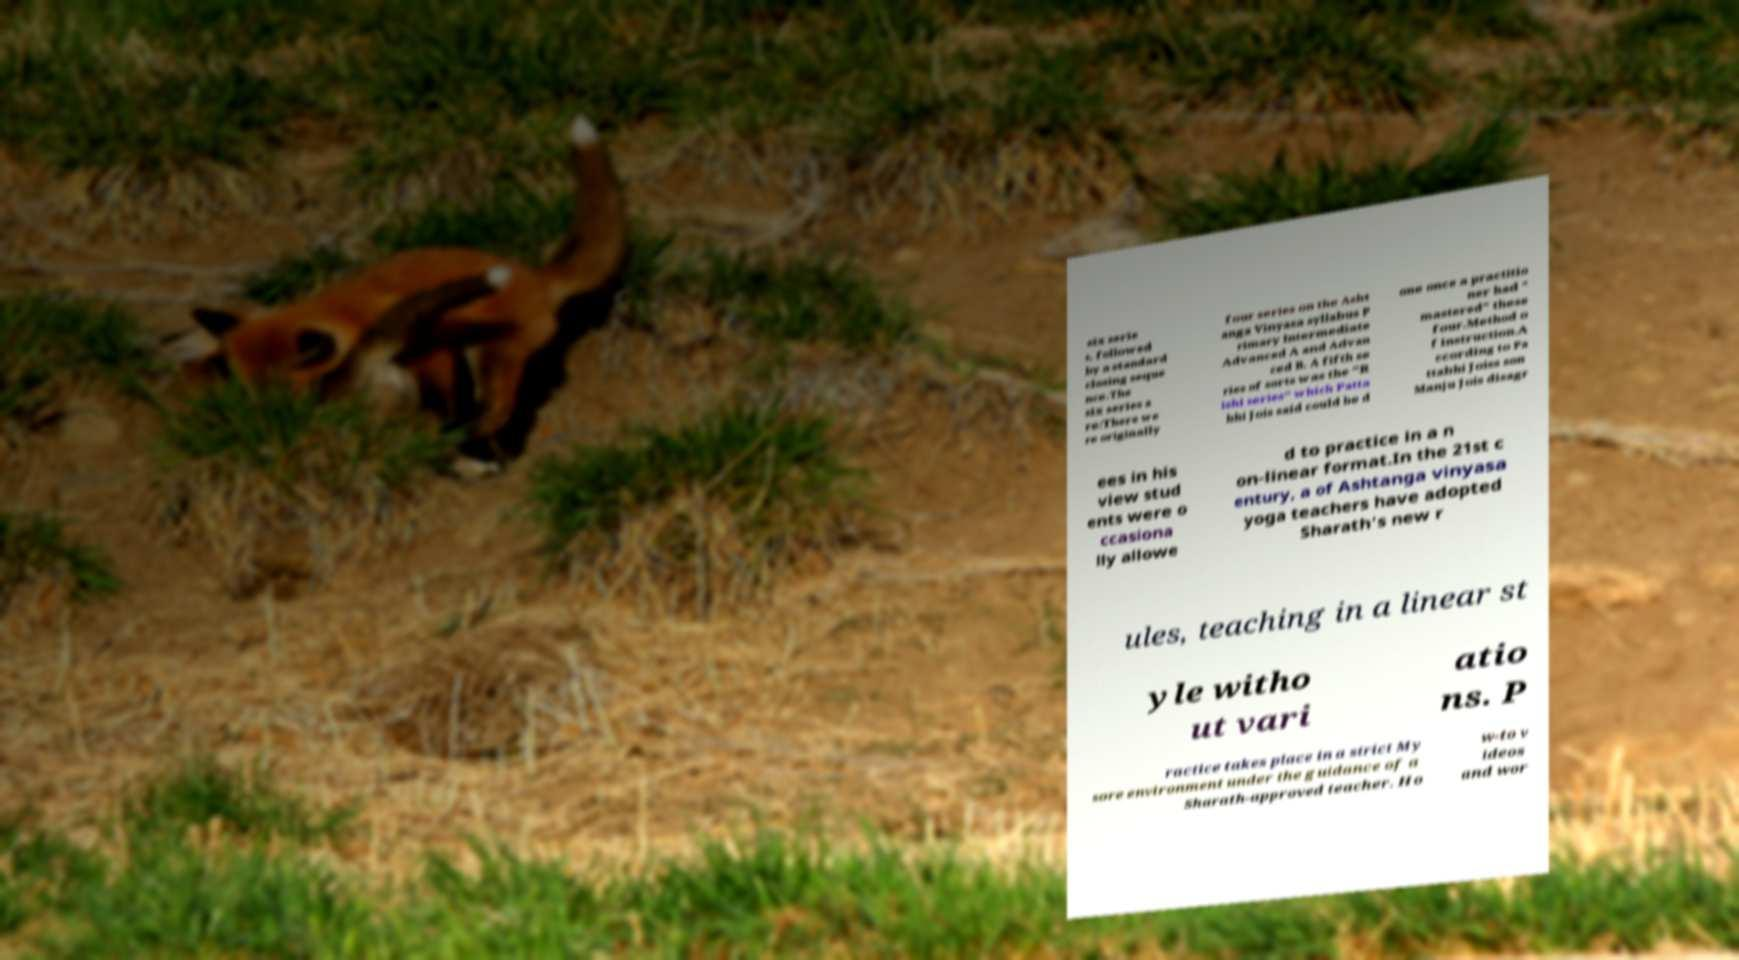Can you read and provide the text displayed in the image?This photo seems to have some interesting text. Can you extract and type it out for me? six serie s, followed by a standard closing seque nce.The six series a re:There we re originally four series on the Asht anga Vinyasa syllabus P rimary Intermediate Advanced A and Advan ced B. A fifth se ries of sorts was the "R ishi series" which Patta bhi Jois said could be d one once a practitio ner had " mastered" these four.Method o f instruction.A ccording to Pa ttabhi Joiss son Manju Jois disagr ees in his view stud ents were o ccasiona lly allowe d to practice in a n on-linear format.In the 21st c entury, a of Ashtanga vinyasa yoga teachers have adopted Sharath's new r ules, teaching in a linear st yle witho ut vari atio ns. P ractice takes place in a strict My sore environment under the guidance of a Sharath-approved teacher. Ho w-to v ideos and wor 